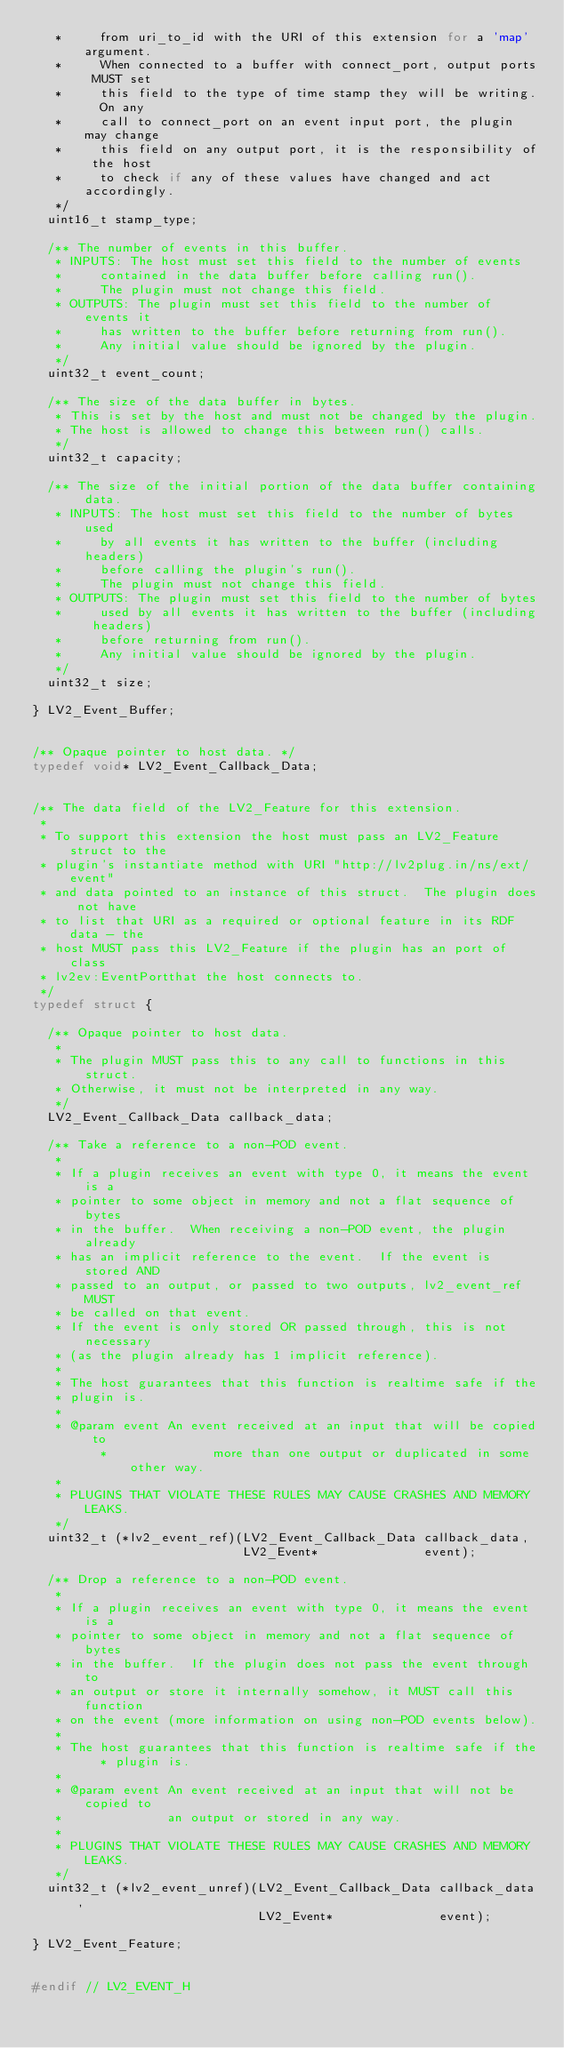Convert code to text. <code><loc_0><loc_0><loc_500><loc_500><_C_>	 *     from uri_to_id with the URI of this extension for a 'map' argument.
	 *     When connected to a buffer with connect_port, output ports MUST set
	 *     this field to the type of time stamp they will be writing.  On any
	 *     call to connect_port on an event input port, the plugin may change
	 *     this field on any output port, it is the responsibility of the host
	 *     to check if any of these values have changed and act accordingly.
	 */
	uint16_t stamp_type;

	/** The number of events in this buffer.
	 * INPUTS: The host must set this field to the number of events
	 *     contained in the data buffer before calling run().
	 *     The plugin must not change this field.
	 * OUTPUTS: The plugin must set this field to the number of events it
	 *     has written to the buffer before returning from run().
	 *     Any initial value should be ignored by the plugin.
	 */
	uint32_t event_count;

	/** The size of the data buffer in bytes.
	 * This is set by the host and must not be changed by the plugin.
	 * The host is allowed to change this between run() calls.
	 */
	uint32_t capacity;

	/** The size of the initial portion of the data buffer containing data.
	 * INPUTS: The host must set this field to the number of bytes used
	 *     by all events it has written to the buffer (including headers)
	 *     before calling the plugin's run().
	 *     The plugin must not change this field.
	 * OUTPUTS: The plugin must set this field to the number of bytes
	 *     used by all events it has written to the buffer (including headers)
	 *     before returning from run().
	 *     Any initial value should be ignored by the plugin.
	 */
	uint32_t size;

} LV2_Event_Buffer;


/** Opaque pointer to host data. */
typedef void* LV2_Event_Callback_Data;


/** The data field of the LV2_Feature for this extension.
 *
 * To support this extension the host must pass an LV2_Feature struct to the
 * plugin's instantiate method with URI "http://lv2plug.in/ns/ext/event"
 * and data pointed to an instance of this struct.  The plugin does not have
 * to list that URI as a required or optional feature in its RDF data - the 
 * host MUST pass this LV2_Feature if the plugin has an port of class 
 * lv2ev:EventPortthat the host connects to.
 */
typedef struct {
	
	/** Opaque pointer to host data.
	 *
	 * The plugin MUST pass this to any call to functions in this struct.
	 * Otherwise, it must not be interpreted in any way.
	 */
	LV2_Event_Callback_Data callback_data;
	
	/** Take a reference to a non-POD event.
	 *
	 * If a plugin receives an event with type 0, it means the event is a
	 * pointer to some object in memory and not a flat sequence of bytes
	 * in the buffer.  When receiving a non-POD event, the plugin already
	 * has an implicit reference to the event.  If the event is stored AND
	 * passed to an output, or passed to two outputs, lv2_event_ref MUST 
	 * be called on that event.
	 * If the event is only stored OR passed through, this is not necessary
	 * (as the plugin already has 1 implicit reference).
	 *
	 * The host guarantees that this function is realtime safe if the 
	 * plugin is.
	 *
	 * @param event An event received at an input that will be copied to
         *              more than one output or duplicated in some other way.
	 * 
	 * PLUGINS THAT VIOLATE THESE RULES MAY CAUSE CRASHES AND MEMORY LEAKS.
	 */
	uint32_t (*lv2_event_ref)(LV2_Event_Callback_Data callback_data,
	                          LV2_Event*              event);
	
	/** Drop a reference to a non-POD event.
	 *
	 * If a plugin receives an event with type 0, it means the event is a
	 * pointer to some object in memory and not a flat sequence of bytes
	 * in the buffer.  If the plugin does not pass the event through to
	 * an output or store it internally somehow, it MUST call this function
	 * on the event (more information on using non-POD events below).
	 *
	 * The host guarantees that this function is realtime safe if the 
         * plugin is.
	 *
	 * @param event An event received at an input that will not be copied to
	 *              an output or stored in any way.
	 *
	 * PLUGINS THAT VIOLATE THESE RULES MAY CAUSE CRASHES AND MEMORY LEAKS.
	 */
	uint32_t (*lv2_event_unref)(LV2_Event_Callback_Data callback_data,
	                            LV2_Event*              event);

} LV2_Event_Feature;


#endif // LV2_EVENT_H

</code> 